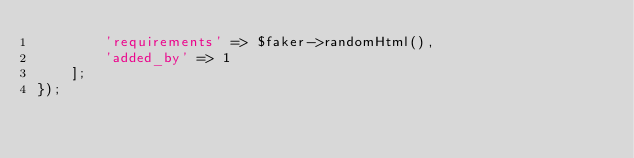<code> <loc_0><loc_0><loc_500><loc_500><_PHP_>        'requirements' => $faker->randomHtml(),
        'added_by' => 1
    ];
});
</code> 